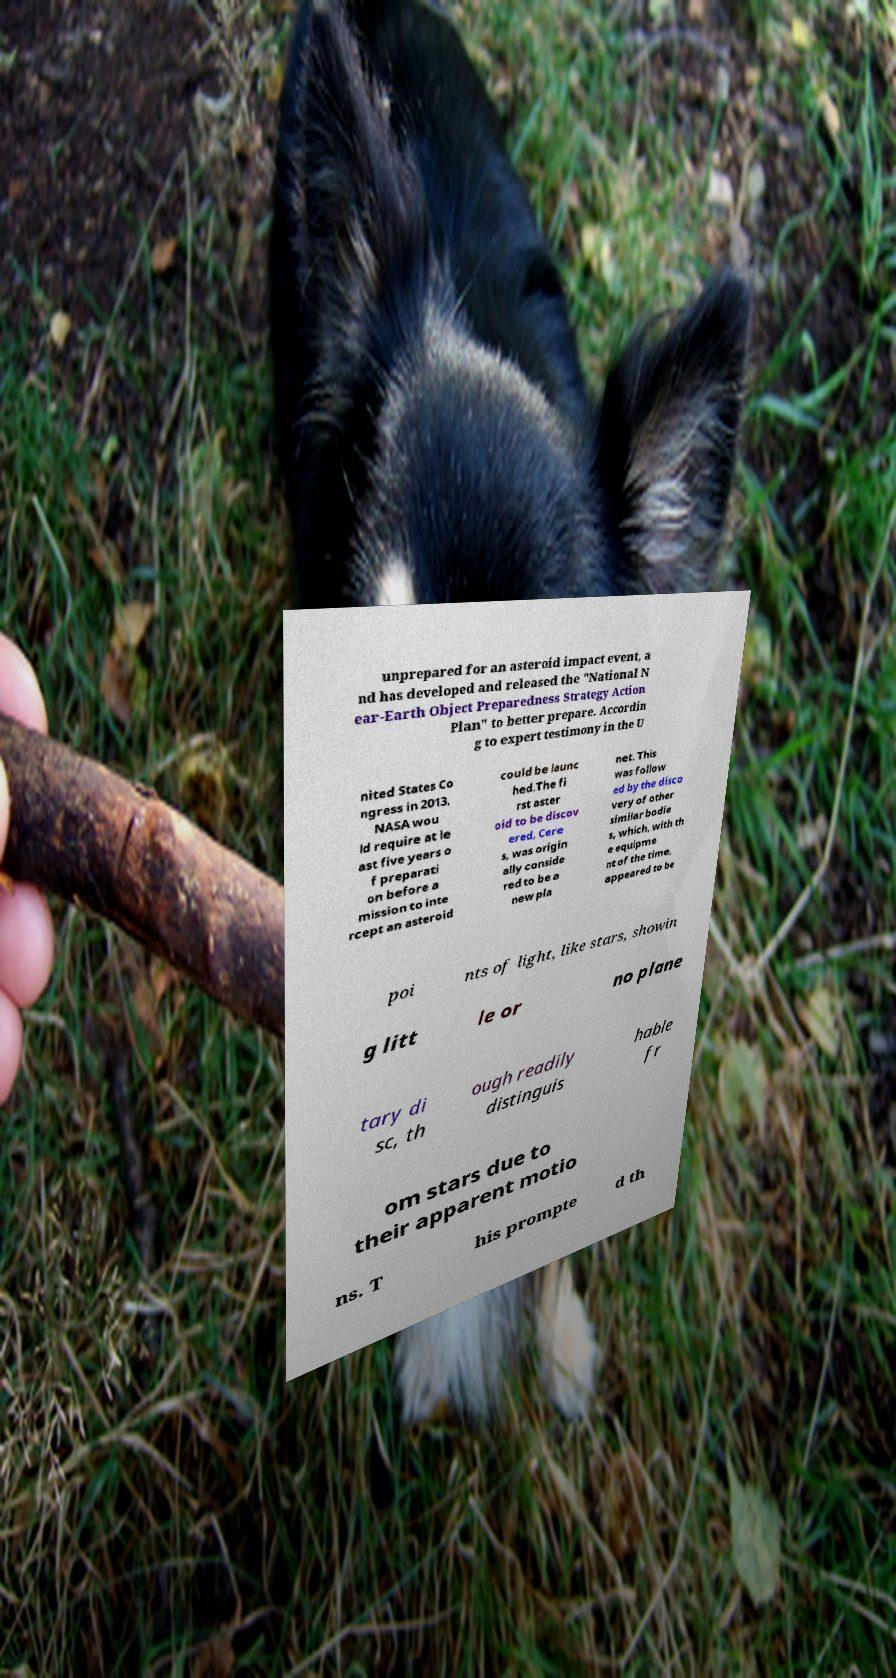Please identify and transcribe the text found in this image. unprepared for an asteroid impact event, a nd has developed and released the "National N ear-Earth Object Preparedness Strategy Action Plan" to better prepare. Accordin g to expert testimony in the U nited States Co ngress in 2013, NASA wou ld require at le ast five years o f preparati on before a mission to inte rcept an asteroid could be launc hed.The fi rst aster oid to be discov ered, Cere s, was origin ally conside red to be a new pla net. This was follow ed by the disco very of other similar bodie s, which, with th e equipme nt of the time, appeared to be poi nts of light, like stars, showin g litt le or no plane tary di sc, th ough readily distinguis hable fr om stars due to their apparent motio ns. T his prompte d th 